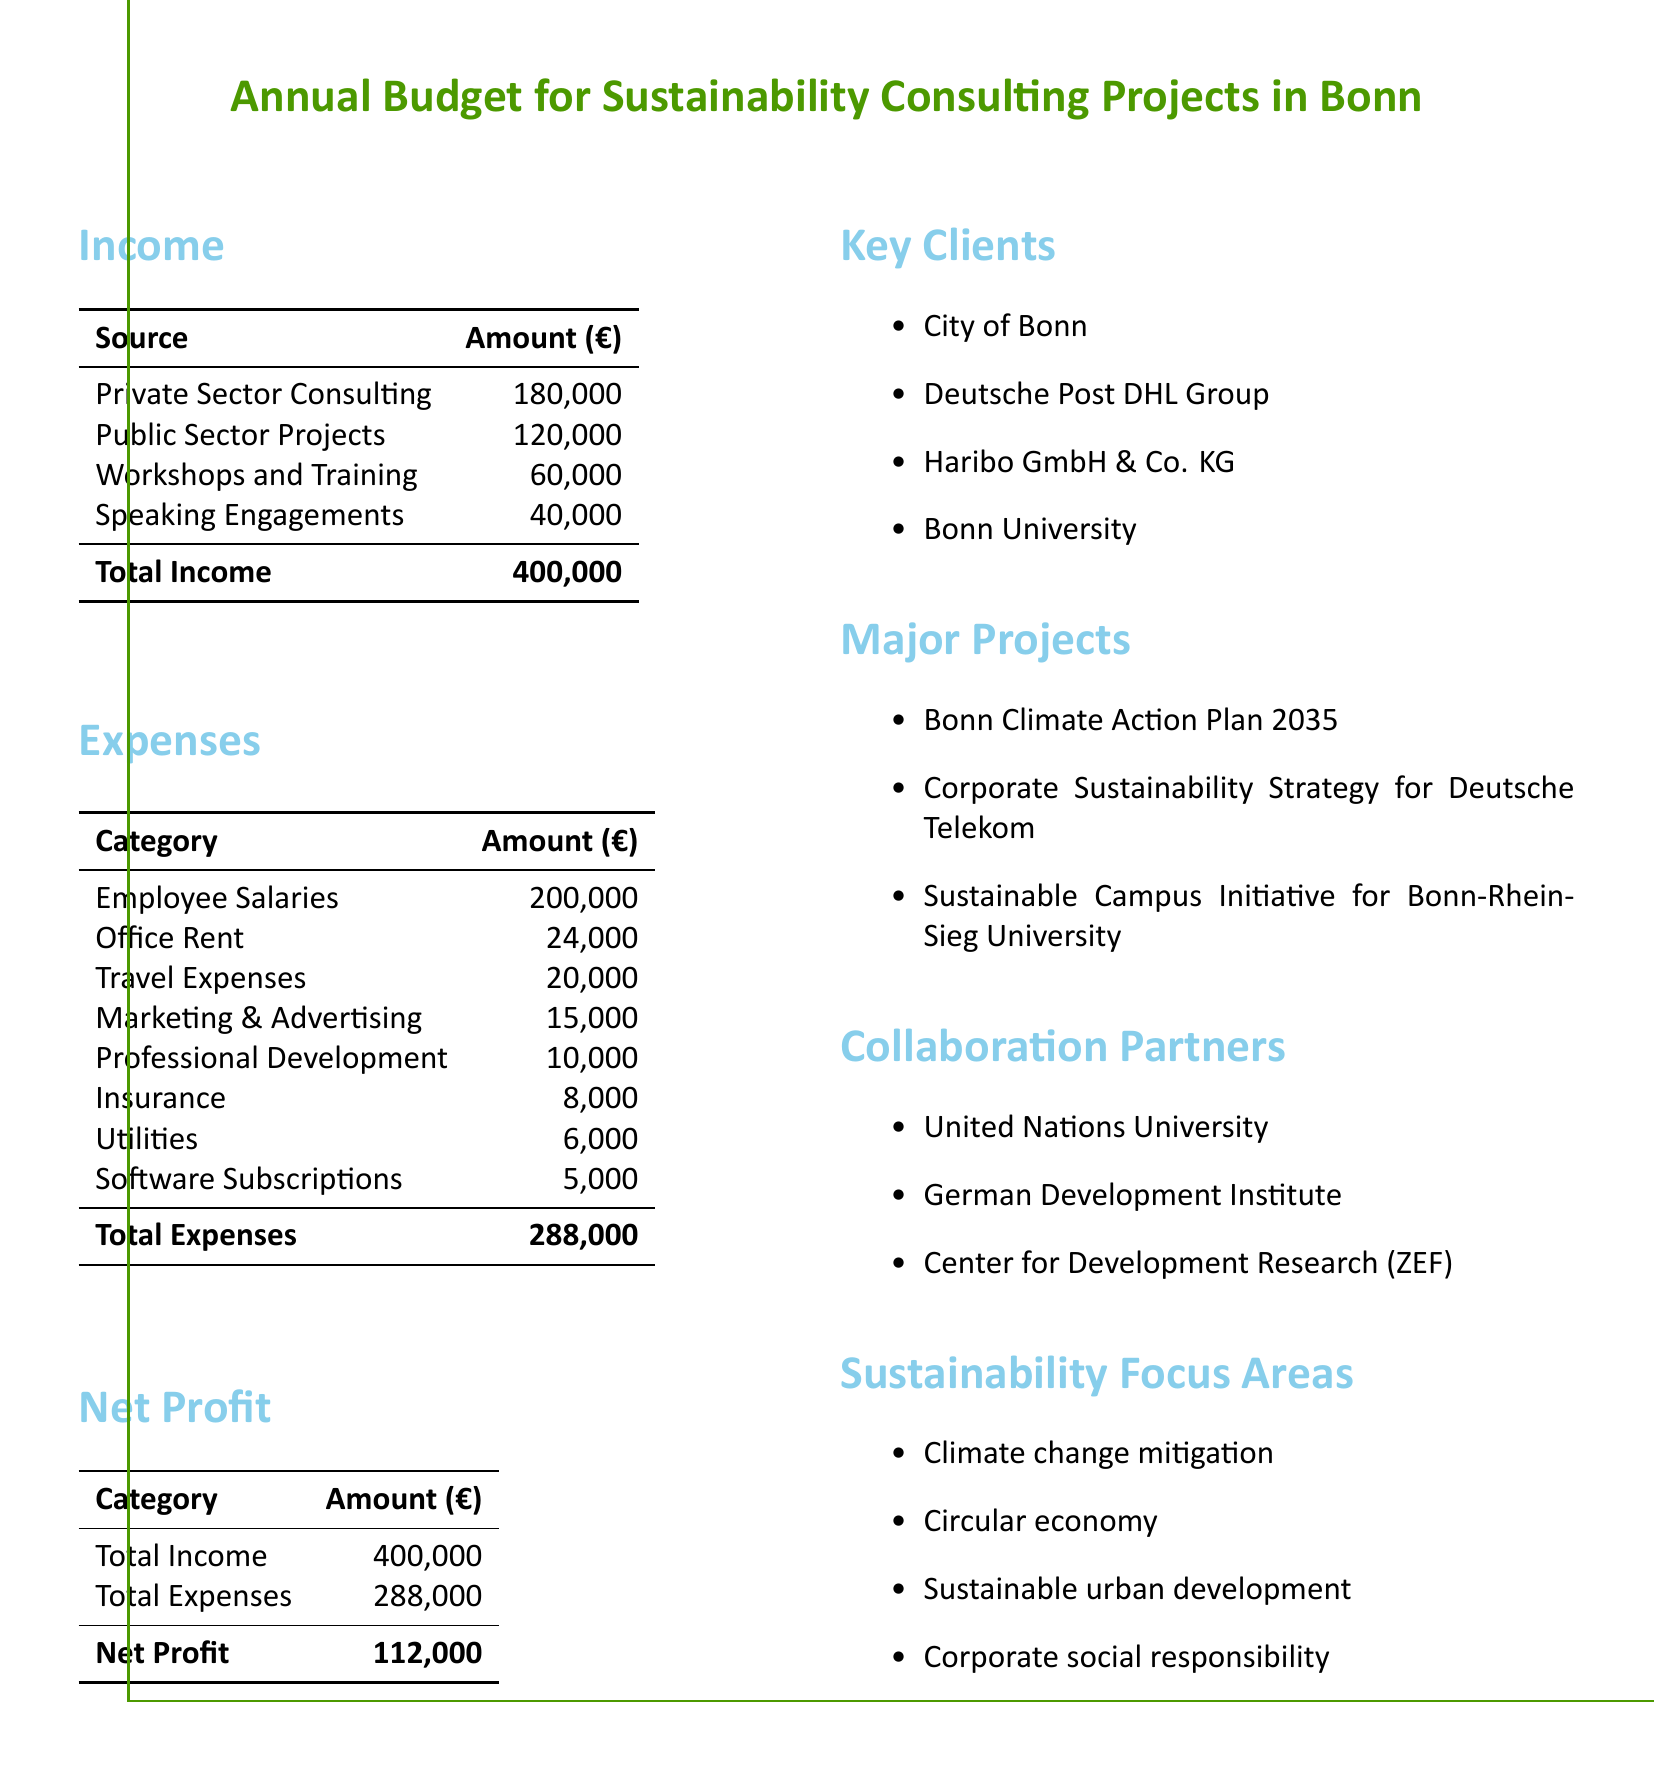what is the total income? The total income is the sum of all income sources in the document, which is 180,000 + 120,000 + 60,000 + 40,000 = 400,000.
Answer: 400,000 what is the amount allocated for employee salaries? The employee salaries are listed under expenses, with an allocation of 200,000.
Answer: 200,000 who are the major clients mentioned? The document lists key clients, which are City of Bonn, Deutsche Post DHL Group, Haribo GmbH & Co. KG, and Bonn University.
Answer: City of Bonn, Deutsche Post DHL Group, Haribo GmbH & Co. KG, Bonn University what is the total expenses figure? The total expenses are the sum of all listed expense categories in the document, which amounts to 288,000.
Answer: 288,000 which project is associated with sustainability in the City of Bonn? The document mentions the Bonn Climate Action Plan 2035 as a major project.
Answer: Bonn Climate Action Plan 2035 what is the net profit for the year? The net profit is calculated by subtracting total expenses from total income, which is 400,000 - 288,000 = 112,000.
Answer: 112,000 how much is budgeted for marketing and advertising? The budget for marketing and advertising is explicitly mentioned as an expense category in the document.
Answer: 15,000 what is one focus area of sustainability mentioned? The document lists multiple sustainability focus areas, including climate change mitigation, which is one of them.
Answer: Climate change mitigation what is the total budget for travel expenses? The travel expenses are specified as a separate line item under expenses with an amount stated in the document.
Answer: 20,000 which organization is listed as a collaboration partner? The document lists several collaboration partners, including the United Nations University.
Answer: United Nations University 